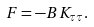<formula> <loc_0><loc_0><loc_500><loc_500>F = - B K _ { \tau \tau } .</formula> 